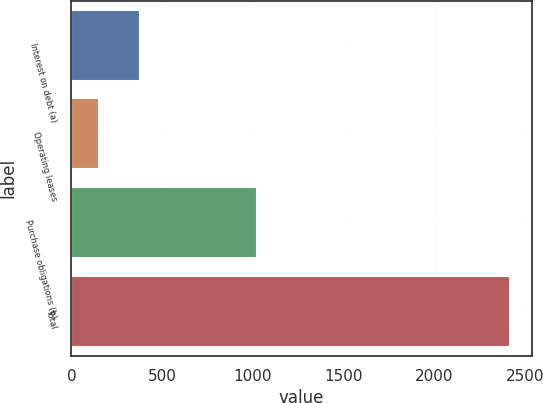Convert chart. <chart><loc_0><loc_0><loc_500><loc_500><bar_chart><fcel>Interest on debt (a)<fcel>Operating leases<fcel>Purchase obligations (b)<fcel>Total<nl><fcel>375.5<fcel>149<fcel>1022<fcel>2414<nl></chart> 